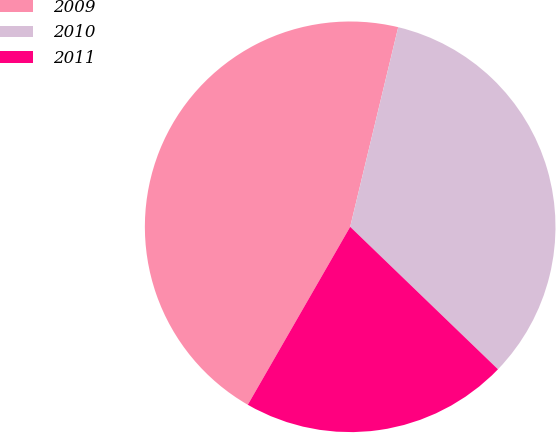Convert chart. <chart><loc_0><loc_0><loc_500><loc_500><pie_chart><fcel>2009<fcel>2010<fcel>2011<nl><fcel>45.45%<fcel>33.45%<fcel>21.1%<nl></chart> 